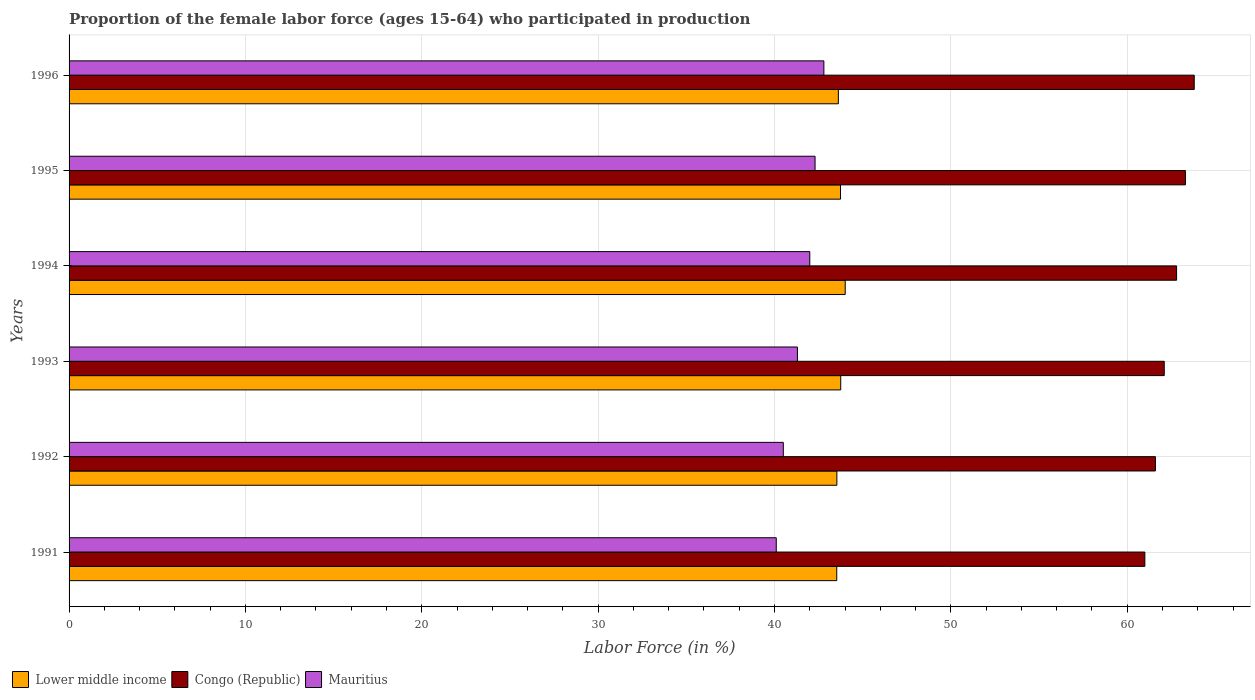How many different coloured bars are there?
Keep it short and to the point. 3. How many groups of bars are there?
Your response must be concise. 6. Are the number of bars per tick equal to the number of legend labels?
Make the answer very short. Yes. What is the label of the 2nd group of bars from the top?
Your answer should be very brief. 1995. What is the proportion of the female labor force who participated in production in Congo (Republic) in 1994?
Give a very brief answer. 62.8. Across all years, what is the maximum proportion of the female labor force who participated in production in Mauritius?
Your answer should be very brief. 42.8. Across all years, what is the minimum proportion of the female labor force who participated in production in Congo (Republic)?
Offer a very short reply. 61. In which year was the proportion of the female labor force who participated in production in Mauritius maximum?
Ensure brevity in your answer.  1996. What is the total proportion of the female labor force who participated in production in Lower middle income in the graph?
Provide a succinct answer. 262.2. What is the difference between the proportion of the female labor force who participated in production in Lower middle income in 1994 and that in 1996?
Offer a terse response. 0.39. What is the difference between the proportion of the female labor force who participated in production in Lower middle income in 1994 and the proportion of the female labor force who participated in production in Mauritius in 1991?
Your answer should be compact. 3.91. What is the average proportion of the female labor force who participated in production in Lower middle income per year?
Your answer should be compact. 43.7. In the year 1996, what is the difference between the proportion of the female labor force who participated in production in Congo (Republic) and proportion of the female labor force who participated in production in Lower middle income?
Your answer should be very brief. 20.18. What is the ratio of the proportion of the female labor force who participated in production in Mauritius in 1994 to that in 1996?
Your answer should be very brief. 0.98. Is the difference between the proportion of the female labor force who participated in production in Congo (Republic) in 1993 and 1996 greater than the difference between the proportion of the female labor force who participated in production in Lower middle income in 1993 and 1996?
Provide a short and direct response. No. What is the difference between the highest and the second highest proportion of the female labor force who participated in production in Congo (Republic)?
Your answer should be compact. 0.5. What is the difference between the highest and the lowest proportion of the female labor force who participated in production in Mauritius?
Provide a succinct answer. 2.7. In how many years, is the proportion of the female labor force who participated in production in Mauritius greater than the average proportion of the female labor force who participated in production in Mauritius taken over all years?
Provide a succinct answer. 3. Is the sum of the proportion of the female labor force who participated in production in Mauritius in 1993 and 1996 greater than the maximum proportion of the female labor force who participated in production in Congo (Republic) across all years?
Your answer should be very brief. Yes. What does the 1st bar from the top in 1991 represents?
Your answer should be very brief. Mauritius. What does the 3rd bar from the bottom in 1993 represents?
Ensure brevity in your answer.  Mauritius. How many years are there in the graph?
Provide a succinct answer. 6. Are the values on the major ticks of X-axis written in scientific E-notation?
Offer a terse response. No. Does the graph contain grids?
Your answer should be compact. Yes. How are the legend labels stacked?
Make the answer very short. Horizontal. What is the title of the graph?
Your response must be concise. Proportion of the female labor force (ages 15-64) who participated in production. Does "United Arab Emirates" appear as one of the legend labels in the graph?
Offer a terse response. No. What is the label or title of the X-axis?
Ensure brevity in your answer.  Labor Force (in %). What is the label or title of the Y-axis?
Ensure brevity in your answer.  Years. What is the Labor Force (in %) in Lower middle income in 1991?
Offer a very short reply. 43.53. What is the Labor Force (in %) of Congo (Republic) in 1991?
Provide a succinct answer. 61. What is the Labor Force (in %) of Mauritius in 1991?
Ensure brevity in your answer.  40.1. What is the Labor Force (in %) of Lower middle income in 1992?
Your answer should be very brief. 43.54. What is the Labor Force (in %) in Congo (Republic) in 1992?
Give a very brief answer. 61.6. What is the Labor Force (in %) in Mauritius in 1992?
Your response must be concise. 40.5. What is the Labor Force (in %) in Lower middle income in 1993?
Provide a short and direct response. 43.76. What is the Labor Force (in %) in Congo (Republic) in 1993?
Offer a very short reply. 62.1. What is the Labor Force (in %) of Mauritius in 1993?
Keep it short and to the point. 41.3. What is the Labor Force (in %) in Lower middle income in 1994?
Your answer should be compact. 44.01. What is the Labor Force (in %) of Congo (Republic) in 1994?
Give a very brief answer. 62.8. What is the Labor Force (in %) of Mauritius in 1994?
Provide a short and direct response. 42. What is the Labor Force (in %) of Lower middle income in 1995?
Offer a very short reply. 43.74. What is the Labor Force (in %) in Congo (Republic) in 1995?
Offer a terse response. 63.3. What is the Labor Force (in %) in Mauritius in 1995?
Make the answer very short. 42.3. What is the Labor Force (in %) of Lower middle income in 1996?
Offer a terse response. 43.62. What is the Labor Force (in %) of Congo (Republic) in 1996?
Give a very brief answer. 63.8. What is the Labor Force (in %) of Mauritius in 1996?
Make the answer very short. 42.8. Across all years, what is the maximum Labor Force (in %) in Lower middle income?
Provide a short and direct response. 44.01. Across all years, what is the maximum Labor Force (in %) in Congo (Republic)?
Provide a short and direct response. 63.8. Across all years, what is the maximum Labor Force (in %) of Mauritius?
Offer a terse response. 42.8. Across all years, what is the minimum Labor Force (in %) of Lower middle income?
Your answer should be very brief. 43.53. Across all years, what is the minimum Labor Force (in %) of Congo (Republic)?
Offer a terse response. 61. Across all years, what is the minimum Labor Force (in %) in Mauritius?
Your response must be concise. 40.1. What is the total Labor Force (in %) of Lower middle income in the graph?
Ensure brevity in your answer.  262.2. What is the total Labor Force (in %) in Congo (Republic) in the graph?
Keep it short and to the point. 374.6. What is the total Labor Force (in %) in Mauritius in the graph?
Keep it short and to the point. 249. What is the difference between the Labor Force (in %) in Lower middle income in 1991 and that in 1992?
Ensure brevity in your answer.  -0.01. What is the difference between the Labor Force (in %) in Lower middle income in 1991 and that in 1993?
Give a very brief answer. -0.23. What is the difference between the Labor Force (in %) in Congo (Republic) in 1991 and that in 1993?
Your response must be concise. -1.1. What is the difference between the Labor Force (in %) in Mauritius in 1991 and that in 1993?
Give a very brief answer. -1.2. What is the difference between the Labor Force (in %) in Lower middle income in 1991 and that in 1994?
Offer a terse response. -0.48. What is the difference between the Labor Force (in %) in Congo (Republic) in 1991 and that in 1994?
Ensure brevity in your answer.  -1.8. What is the difference between the Labor Force (in %) in Mauritius in 1991 and that in 1994?
Offer a terse response. -1.9. What is the difference between the Labor Force (in %) of Lower middle income in 1991 and that in 1995?
Ensure brevity in your answer.  -0.21. What is the difference between the Labor Force (in %) in Mauritius in 1991 and that in 1995?
Your answer should be compact. -2.2. What is the difference between the Labor Force (in %) in Lower middle income in 1991 and that in 1996?
Your answer should be very brief. -0.09. What is the difference between the Labor Force (in %) of Congo (Republic) in 1991 and that in 1996?
Ensure brevity in your answer.  -2.8. What is the difference between the Labor Force (in %) of Lower middle income in 1992 and that in 1993?
Offer a terse response. -0.22. What is the difference between the Labor Force (in %) of Mauritius in 1992 and that in 1993?
Offer a terse response. -0.8. What is the difference between the Labor Force (in %) in Lower middle income in 1992 and that in 1994?
Provide a short and direct response. -0.47. What is the difference between the Labor Force (in %) in Lower middle income in 1992 and that in 1995?
Make the answer very short. -0.21. What is the difference between the Labor Force (in %) in Congo (Republic) in 1992 and that in 1995?
Offer a very short reply. -1.7. What is the difference between the Labor Force (in %) of Mauritius in 1992 and that in 1995?
Provide a short and direct response. -1.8. What is the difference between the Labor Force (in %) of Lower middle income in 1992 and that in 1996?
Your answer should be compact. -0.08. What is the difference between the Labor Force (in %) in Lower middle income in 1993 and that in 1994?
Provide a short and direct response. -0.25. What is the difference between the Labor Force (in %) in Congo (Republic) in 1993 and that in 1994?
Make the answer very short. -0.7. What is the difference between the Labor Force (in %) of Mauritius in 1993 and that in 1994?
Give a very brief answer. -0.7. What is the difference between the Labor Force (in %) of Lower middle income in 1993 and that in 1995?
Give a very brief answer. 0.01. What is the difference between the Labor Force (in %) of Congo (Republic) in 1993 and that in 1995?
Your response must be concise. -1.2. What is the difference between the Labor Force (in %) of Mauritius in 1993 and that in 1995?
Ensure brevity in your answer.  -1. What is the difference between the Labor Force (in %) of Lower middle income in 1993 and that in 1996?
Your answer should be compact. 0.14. What is the difference between the Labor Force (in %) in Congo (Republic) in 1993 and that in 1996?
Offer a terse response. -1.7. What is the difference between the Labor Force (in %) in Lower middle income in 1994 and that in 1995?
Your response must be concise. 0.27. What is the difference between the Labor Force (in %) of Congo (Republic) in 1994 and that in 1995?
Your answer should be compact. -0.5. What is the difference between the Labor Force (in %) of Lower middle income in 1994 and that in 1996?
Your response must be concise. 0.39. What is the difference between the Labor Force (in %) of Lower middle income in 1995 and that in 1996?
Make the answer very short. 0.12. What is the difference between the Labor Force (in %) of Mauritius in 1995 and that in 1996?
Ensure brevity in your answer.  -0.5. What is the difference between the Labor Force (in %) in Lower middle income in 1991 and the Labor Force (in %) in Congo (Republic) in 1992?
Make the answer very short. -18.07. What is the difference between the Labor Force (in %) of Lower middle income in 1991 and the Labor Force (in %) of Mauritius in 1992?
Offer a terse response. 3.03. What is the difference between the Labor Force (in %) in Congo (Republic) in 1991 and the Labor Force (in %) in Mauritius in 1992?
Offer a terse response. 20.5. What is the difference between the Labor Force (in %) in Lower middle income in 1991 and the Labor Force (in %) in Congo (Republic) in 1993?
Your answer should be compact. -18.57. What is the difference between the Labor Force (in %) in Lower middle income in 1991 and the Labor Force (in %) in Mauritius in 1993?
Offer a very short reply. 2.23. What is the difference between the Labor Force (in %) of Congo (Republic) in 1991 and the Labor Force (in %) of Mauritius in 1993?
Make the answer very short. 19.7. What is the difference between the Labor Force (in %) of Lower middle income in 1991 and the Labor Force (in %) of Congo (Republic) in 1994?
Offer a terse response. -19.27. What is the difference between the Labor Force (in %) in Lower middle income in 1991 and the Labor Force (in %) in Mauritius in 1994?
Offer a terse response. 1.53. What is the difference between the Labor Force (in %) in Lower middle income in 1991 and the Labor Force (in %) in Congo (Republic) in 1995?
Ensure brevity in your answer.  -19.77. What is the difference between the Labor Force (in %) of Lower middle income in 1991 and the Labor Force (in %) of Mauritius in 1995?
Your answer should be compact. 1.23. What is the difference between the Labor Force (in %) of Congo (Republic) in 1991 and the Labor Force (in %) of Mauritius in 1995?
Your answer should be compact. 18.7. What is the difference between the Labor Force (in %) in Lower middle income in 1991 and the Labor Force (in %) in Congo (Republic) in 1996?
Give a very brief answer. -20.27. What is the difference between the Labor Force (in %) in Lower middle income in 1991 and the Labor Force (in %) in Mauritius in 1996?
Your answer should be compact. 0.73. What is the difference between the Labor Force (in %) of Lower middle income in 1992 and the Labor Force (in %) of Congo (Republic) in 1993?
Keep it short and to the point. -18.56. What is the difference between the Labor Force (in %) of Lower middle income in 1992 and the Labor Force (in %) of Mauritius in 1993?
Offer a terse response. 2.24. What is the difference between the Labor Force (in %) in Congo (Republic) in 1992 and the Labor Force (in %) in Mauritius in 1993?
Your answer should be very brief. 20.3. What is the difference between the Labor Force (in %) of Lower middle income in 1992 and the Labor Force (in %) of Congo (Republic) in 1994?
Offer a terse response. -19.26. What is the difference between the Labor Force (in %) of Lower middle income in 1992 and the Labor Force (in %) of Mauritius in 1994?
Offer a terse response. 1.54. What is the difference between the Labor Force (in %) in Congo (Republic) in 1992 and the Labor Force (in %) in Mauritius in 1994?
Provide a succinct answer. 19.6. What is the difference between the Labor Force (in %) in Lower middle income in 1992 and the Labor Force (in %) in Congo (Republic) in 1995?
Make the answer very short. -19.76. What is the difference between the Labor Force (in %) in Lower middle income in 1992 and the Labor Force (in %) in Mauritius in 1995?
Provide a succinct answer. 1.24. What is the difference between the Labor Force (in %) of Congo (Republic) in 1992 and the Labor Force (in %) of Mauritius in 1995?
Ensure brevity in your answer.  19.3. What is the difference between the Labor Force (in %) of Lower middle income in 1992 and the Labor Force (in %) of Congo (Republic) in 1996?
Provide a short and direct response. -20.26. What is the difference between the Labor Force (in %) in Lower middle income in 1992 and the Labor Force (in %) in Mauritius in 1996?
Give a very brief answer. 0.74. What is the difference between the Labor Force (in %) in Congo (Republic) in 1992 and the Labor Force (in %) in Mauritius in 1996?
Offer a terse response. 18.8. What is the difference between the Labor Force (in %) of Lower middle income in 1993 and the Labor Force (in %) of Congo (Republic) in 1994?
Ensure brevity in your answer.  -19.04. What is the difference between the Labor Force (in %) of Lower middle income in 1993 and the Labor Force (in %) of Mauritius in 1994?
Keep it short and to the point. 1.76. What is the difference between the Labor Force (in %) in Congo (Republic) in 1993 and the Labor Force (in %) in Mauritius in 1994?
Ensure brevity in your answer.  20.1. What is the difference between the Labor Force (in %) in Lower middle income in 1993 and the Labor Force (in %) in Congo (Republic) in 1995?
Your response must be concise. -19.54. What is the difference between the Labor Force (in %) in Lower middle income in 1993 and the Labor Force (in %) in Mauritius in 1995?
Ensure brevity in your answer.  1.46. What is the difference between the Labor Force (in %) of Congo (Republic) in 1993 and the Labor Force (in %) of Mauritius in 1995?
Offer a very short reply. 19.8. What is the difference between the Labor Force (in %) of Lower middle income in 1993 and the Labor Force (in %) of Congo (Republic) in 1996?
Make the answer very short. -20.04. What is the difference between the Labor Force (in %) in Lower middle income in 1993 and the Labor Force (in %) in Mauritius in 1996?
Keep it short and to the point. 0.96. What is the difference between the Labor Force (in %) in Congo (Republic) in 1993 and the Labor Force (in %) in Mauritius in 1996?
Your answer should be compact. 19.3. What is the difference between the Labor Force (in %) of Lower middle income in 1994 and the Labor Force (in %) of Congo (Republic) in 1995?
Your response must be concise. -19.29. What is the difference between the Labor Force (in %) of Lower middle income in 1994 and the Labor Force (in %) of Mauritius in 1995?
Ensure brevity in your answer.  1.71. What is the difference between the Labor Force (in %) of Congo (Republic) in 1994 and the Labor Force (in %) of Mauritius in 1995?
Offer a very short reply. 20.5. What is the difference between the Labor Force (in %) in Lower middle income in 1994 and the Labor Force (in %) in Congo (Republic) in 1996?
Offer a terse response. -19.79. What is the difference between the Labor Force (in %) in Lower middle income in 1994 and the Labor Force (in %) in Mauritius in 1996?
Keep it short and to the point. 1.21. What is the difference between the Labor Force (in %) in Lower middle income in 1995 and the Labor Force (in %) in Congo (Republic) in 1996?
Your response must be concise. -20.06. What is the difference between the Labor Force (in %) of Lower middle income in 1995 and the Labor Force (in %) of Mauritius in 1996?
Make the answer very short. 0.94. What is the difference between the Labor Force (in %) of Congo (Republic) in 1995 and the Labor Force (in %) of Mauritius in 1996?
Your answer should be compact. 20.5. What is the average Labor Force (in %) in Lower middle income per year?
Your answer should be compact. 43.7. What is the average Labor Force (in %) in Congo (Republic) per year?
Provide a succinct answer. 62.43. What is the average Labor Force (in %) in Mauritius per year?
Your response must be concise. 41.5. In the year 1991, what is the difference between the Labor Force (in %) of Lower middle income and Labor Force (in %) of Congo (Republic)?
Your answer should be compact. -17.47. In the year 1991, what is the difference between the Labor Force (in %) in Lower middle income and Labor Force (in %) in Mauritius?
Offer a terse response. 3.43. In the year 1991, what is the difference between the Labor Force (in %) of Congo (Republic) and Labor Force (in %) of Mauritius?
Give a very brief answer. 20.9. In the year 1992, what is the difference between the Labor Force (in %) in Lower middle income and Labor Force (in %) in Congo (Republic)?
Your answer should be compact. -18.06. In the year 1992, what is the difference between the Labor Force (in %) of Lower middle income and Labor Force (in %) of Mauritius?
Keep it short and to the point. 3.04. In the year 1992, what is the difference between the Labor Force (in %) in Congo (Republic) and Labor Force (in %) in Mauritius?
Your response must be concise. 21.1. In the year 1993, what is the difference between the Labor Force (in %) in Lower middle income and Labor Force (in %) in Congo (Republic)?
Provide a short and direct response. -18.34. In the year 1993, what is the difference between the Labor Force (in %) of Lower middle income and Labor Force (in %) of Mauritius?
Your answer should be very brief. 2.46. In the year 1993, what is the difference between the Labor Force (in %) in Congo (Republic) and Labor Force (in %) in Mauritius?
Provide a short and direct response. 20.8. In the year 1994, what is the difference between the Labor Force (in %) of Lower middle income and Labor Force (in %) of Congo (Republic)?
Provide a short and direct response. -18.79. In the year 1994, what is the difference between the Labor Force (in %) in Lower middle income and Labor Force (in %) in Mauritius?
Your response must be concise. 2.01. In the year 1994, what is the difference between the Labor Force (in %) of Congo (Republic) and Labor Force (in %) of Mauritius?
Ensure brevity in your answer.  20.8. In the year 1995, what is the difference between the Labor Force (in %) of Lower middle income and Labor Force (in %) of Congo (Republic)?
Your response must be concise. -19.56. In the year 1995, what is the difference between the Labor Force (in %) of Lower middle income and Labor Force (in %) of Mauritius?
Keep it short and to the point. 1.44. In the year 1995, what is the difference between the Labor Force (in %) of Congo (Republic) and Labor Force (in %) of Mauritius?
Keep it short and to the point. 21. In the year 1996, what is the difference between the Labor Force (in %) of Lower middle income and Labor Force (in %) of Congo (Republic)?
Make the answer very short. -20.18. In the year 1996, what is the difference between the Labor Force (in %) of Lower middle income and Labor Force (in %) of Mauritius?
Ensure brevity in your answer.  0.82. In the year 1996, what is the difference between the Labor Force (in %) of Congo (Republic) and Labor Force (in %) of Mauritius?
Keep it short and to the point. 21. What is the ratio of the Labor Force (in %) of Lower middle income in 1991 to that in 1992?
Keep it short and to the point. 1. What is the ratio of the Labor Force (in %) of Congo (Republic) in 1991 to that in 1992?
Offer a very short reply. 0.99. What is the ratio of the Labor Force (in %) of Lower middle income in 1991 to that in 1993?
Ensure brevity in your answer.  0.99. What is the ratio of the Labor Force (in %) of Congo (Republic) in 1991 to that in 1993?
Your answer should be compact. 0.98. What is the ratio of the Labor Force (in %) of Mauritius in 1991 to that in 1993?
Offer a very short reply. 0.97. What is the ratio of the Labor Force (in %) of Congo (Republic) in 1991 to that in 1994?
Your answer should be very brief. 0.97. What is the ratio of the Labor Force (in %) in Mauritius in 1991 to that in 1994?
Provide a succinct answer. 0.95. What is the ratio of the Labor Force (in %) of Lower middle income in 1991 to that in 1995?
Provide a succinct answer. 1. What is the ratio of the Labor Force (in %) in Congo (Republic) in 1991 to that in 1995?
Provide a succinct answer. 0.96. What is the ratio of the Labor Force (in %) in Mauritius in 1991 to that in 1995?
Your response must be concise. 0.95. What is the ratio of the Labor Force (in %) of Lower middle income in 1991 to that in 1996?
Make the answer very short. 1. What is the ratio of the Labor Force (in %) of Congo (Republic) in 1991 to that in 1996?
Your answer should be compact. 0.96. What is the ratio of the Labor Force (in %) in Mauritius in 1991 to that in 1996?
Ensure brevity in your answer.  0.94. What is the ratio of the Labor Force (in %) of Lower middle income in 1992 to that in 1993?
Make the answer very short. 0.99. What is the ratio of the Labor Force (in %) in Congo (Republic) in 1992 to that in 1993?
Offer a terse response. 0.99. What is the ratio of the Labor Force (in %) of Mauritius in 1992 to that in 1993?
Give a very brief answer. 0.98. What is the ratio of the Labor Force (in %) in Lower middle income in 1992 to that in 1994?
Your answer should be very brief. 0.99. What is the ratio of the Labor Force (in %) in Congo (Republic) in 1992 to that in 1994?
Provide a short and direct response. 0.98. What is the ratio of the Labor Force (in %) of Lower middle income in 1992 to that in 1995?
Ensure brevity in your answer.  1. What is the ratio of the Labor Force (in %) of Congo (Republic) in 1992 to that in 1995?
Your answer should be very brief. 0.97. What is the ratio of the Labor Force (in %) in Mauritius in 1992 to that in 1995?
Your answer should be very brief. 0.96. What is the ratio of the Labor Force (in %) in Congo (Republic) in 1992 to that in 1996?
Keep it short and to the point. 0.97. What is the ratio of the Labor Force (in %) in Mauritius in 1992 to that in 1996?
Offer a very short reply. 0.95. What is the ratio of the Labor Force (in %) of Congo (Republic) in 1993 to that in 1994?
Provide a short and direct response. 0.99. What is the ratio of the Labor Force (in %) of Mauritius in 1993 to that in 1994?
Your answer should be compact. 0.98. What is the ratio of the Labor Force (in %) in Congo (Republic) in 1993 to that in 1995?
Provide a short and direct response. 0.98. What is the ratio of the Labor Force (in %) in Mauritius in 1993 to that in 1995?
Offer a very short reply. 0.98. What is the ratio of the Labor Force (in %) in Lower middle income in 1993 to that in 1996?
Your response must be concise. 1. What is the ratio of the Labor Force (in %) of Congo (Republic) in 1993 to that in 1996?
Ensure brevity in your answer.  0.97. What is the ratio of the Labor Force (in %) of Mauritius in 1993 to that in 1996?
Offer a terse response. 0.96. What is the ratio of the Labor Force (in %) in Mauritius in 1994 to that in 1995?
Your answer should be very brief. 0.99. What is the ratio of the Labor Force (in %) in Lower middle income in 1994 to that in 1996?
Offer a very short reply. 1.01. What is the ratio of the Labor Force (in %) of Congo (Republic) in 1994 to that in 1996?
Keep it short and to the point. 0.98. What is the ratio of the Labor Force (in %) in Mauritius in 1994 to that in 1996?
Give a very brief answer. 0.98. What is the ratio of the Labor Force (in %) in Mauritius in 1995 to that in 1996?
Your response must be concise. 0.99. What is the difference between the highest and the second highest Labor Force (in %) of Lower middle income?
Your answer should be very brief. 0.25. What is the difference between the highest and the lowest Labor Force (in %) of Lower middle income?
Provide a succinct answer. 0.48. What is the difference between the highest and the lowest Labor Force (in %) of Congo (Republic)?
Offer a very short reply. 2.8. What is the difference between the highest and the lowest Labor Force (in %) of Mauritius?
Your response must be concise. 2.7. 